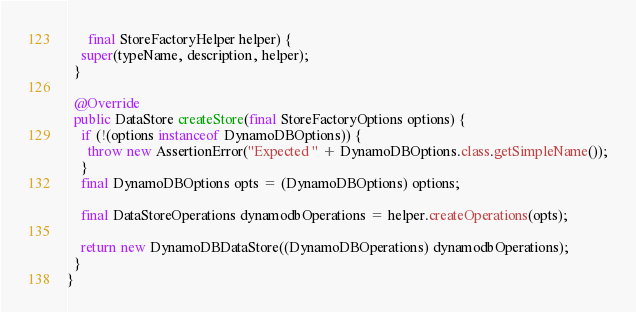Convert code to text. <code><loc_0><loc_0><loc_500><loc_500><_Java_>      final StoreFactoryHelper helper) {
    super(typeName, description, helper);
  }

  @Override
  public DataStore createStore(final StoreFactoryOptions options) {
    if (!(options instanceof DynamoDBOptions)) {
      throw new AssertionError("Expected " + DynamoDBOptions.class.getSimpleName());
    }
    final DynamoDBOptions opts = (DynamoDBOptions) options;

    final DataStoreOperations dynamodbOperations = helper.createOperations(opts);

    return new DynamoDBDataStore((DynamoDBOperations) dynamodbOperations);
  }
}
</code> 